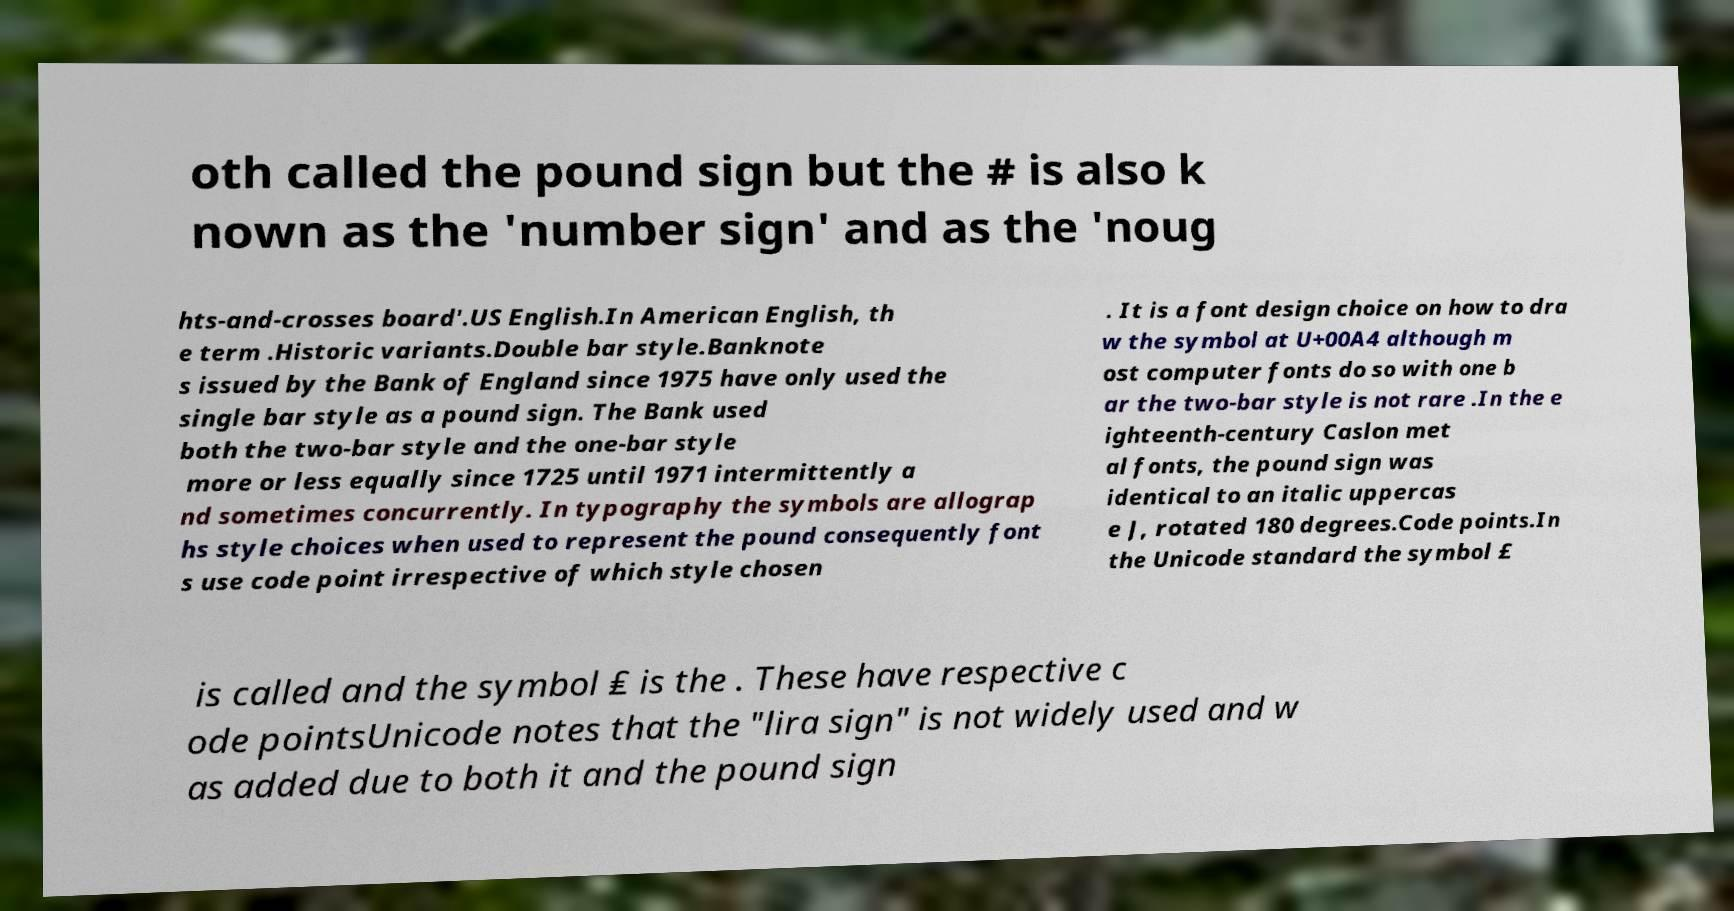There's text embedded in this image that I need extracted. Can you transcribe it verbatim? oth called the pound sign but the # is also k nown as the 'number sign' and as the 'noug hts-and-crosses board'.US English.In American English, th e term .Historic variants.Double bar style.Banknote s issued by the Bank of England since 1975 have only used the single bar style as a pound sign. The Bank used both the two-bar style and the one-bar style more or less equally since 1725 until 1971 intermittently a nd sometimes concurrently. In typography the symbols are allograp hs style choices when used to represent the pound consequently font s use code point irrespective of which style chosen . It is a font design choice on how to dra w the symbol at U+00A4 although m ost computer fonts do so with one b ar the two-bar style is not rare .In the e ighteenth-century Caslon met al fonts, the pound sign was identical to an italic uppercas e J, rotated 180 degrees.Code points.In the Unicode standard the symbol £ is called and the symbol ₤ is the . These have respective c ode pointsUnicode notes that the "lira sign" is not widely used and w as added due to both it and the pound sign 